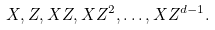Convert formula to latex. <formula><loc_0><loc_0><loc_500><loc_500>X , Z , X Z , X Z ^ { 2 } , \dots , X Z ^ { d - 1 } .</formula> 